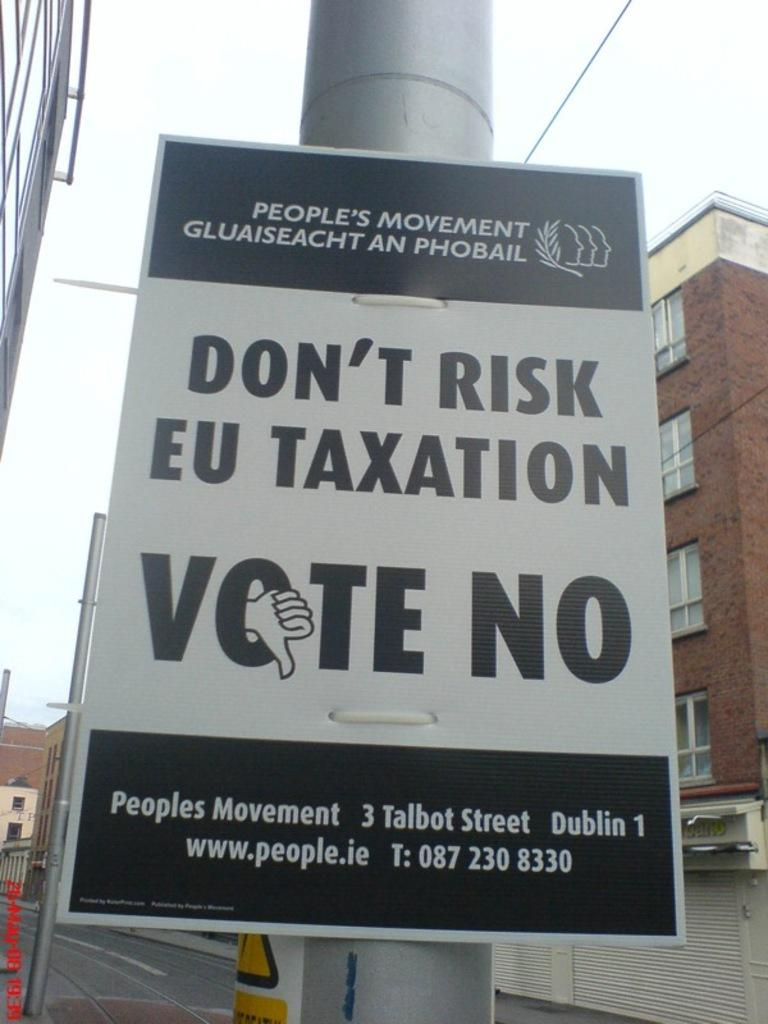Provide a one-sentence caption for the provided image. A political sign put out by the People's Movement promoting no taxation. 